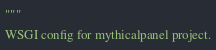Convert code to text. <code><loc_0><loc_0><loc_500><loc_500><_Python_>"""
WSGI config for mythicalpanel project.
</code> 